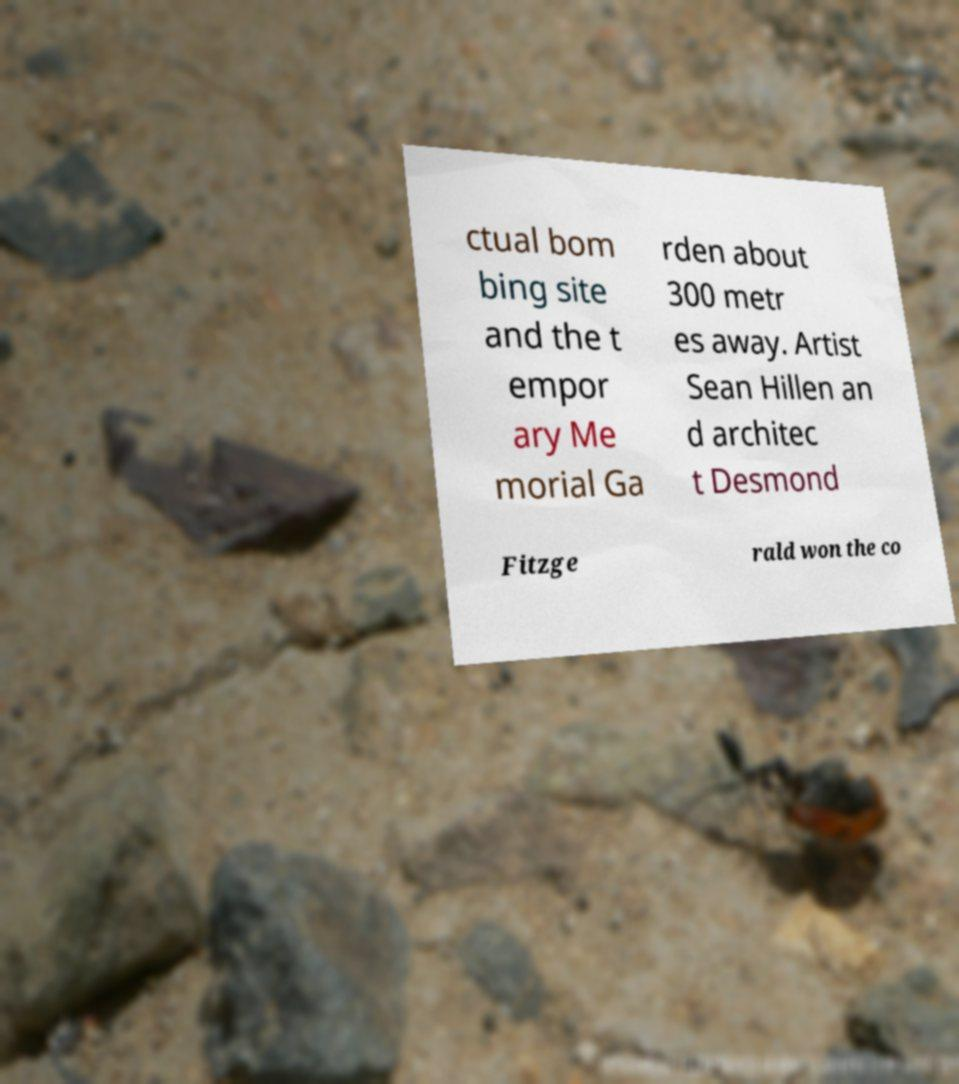What messages or text are displayed in this image? I need them in a readable, typed format. ctual bom bing site and the t empor ary Me morial Ga rden about 300 metr es away. Artist Sean Hillen an d architec t Desmond Fitzge rald won the co 